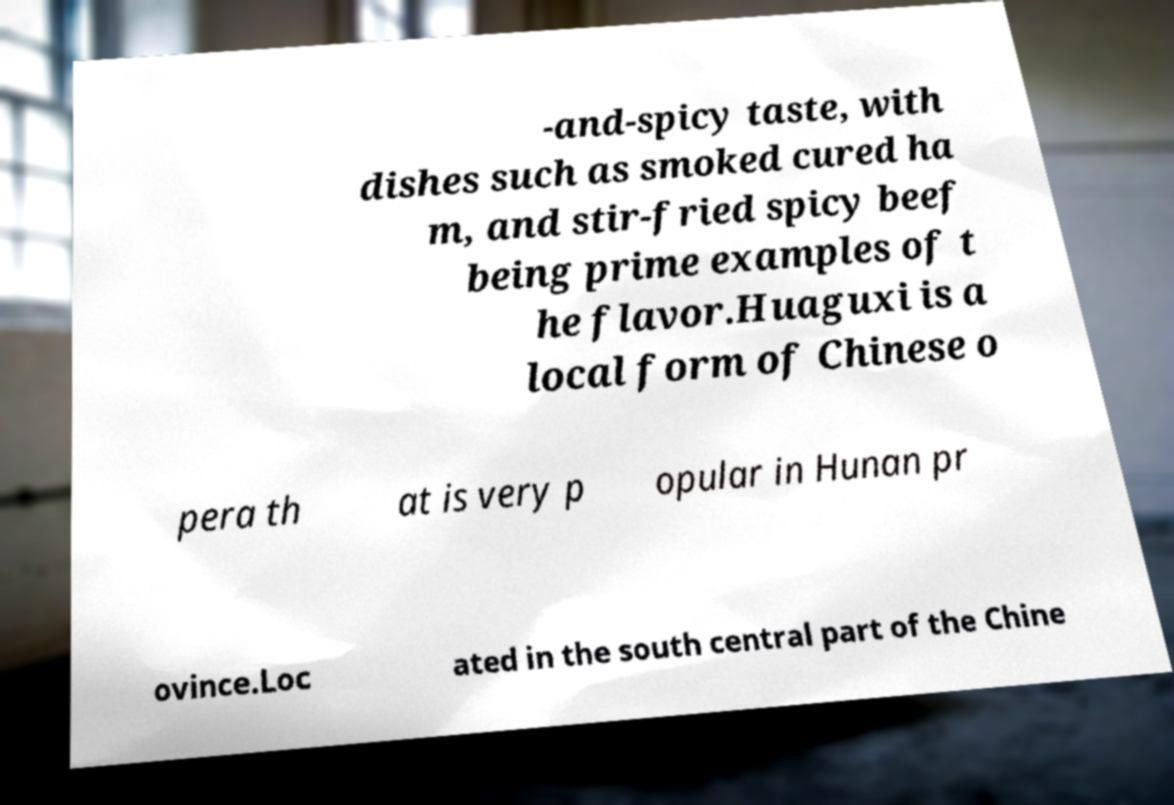Please identify and transcribe the text found in this image. -and-spicy taste, with dishes such as smoked cured ha m, and stir-fried spicy beef being prime examples of t he flavor.Huaguxi is a local form of Chinese o pera th at is very p opular in Hunan pr ovince.Loc ated in the south central part of the Chine 